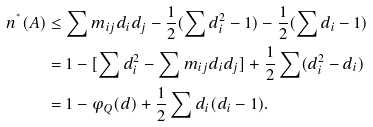<formula> <loc_0><loc_0><loc_500><loc_500>n ^ { ^ { * } } ( A ) & \leq \sum m _ { i j } d _ { i } d _ { j } - \frac { 1 } { 2 } ( \sum d _ { i } ^ { 2 } - 1 ) - \frac { 1 } { 2 } ( \sum d _ { i } - 1 ) \\ & = 1 - [ \sum d _ { i } ^ { 2 } - \sum m _ { i j } d _ { i } d _ { j } ] + \frac { 1 } { 2 } \sum ( d _ { i } ^ { 2 } - d _ { i } ) \\ & = 1 - \varphi _ { Q } ( d ) + \frac { 1 } { 2 } \sum d _ { i } ( d _ { i } - 1 ) .</formula> 